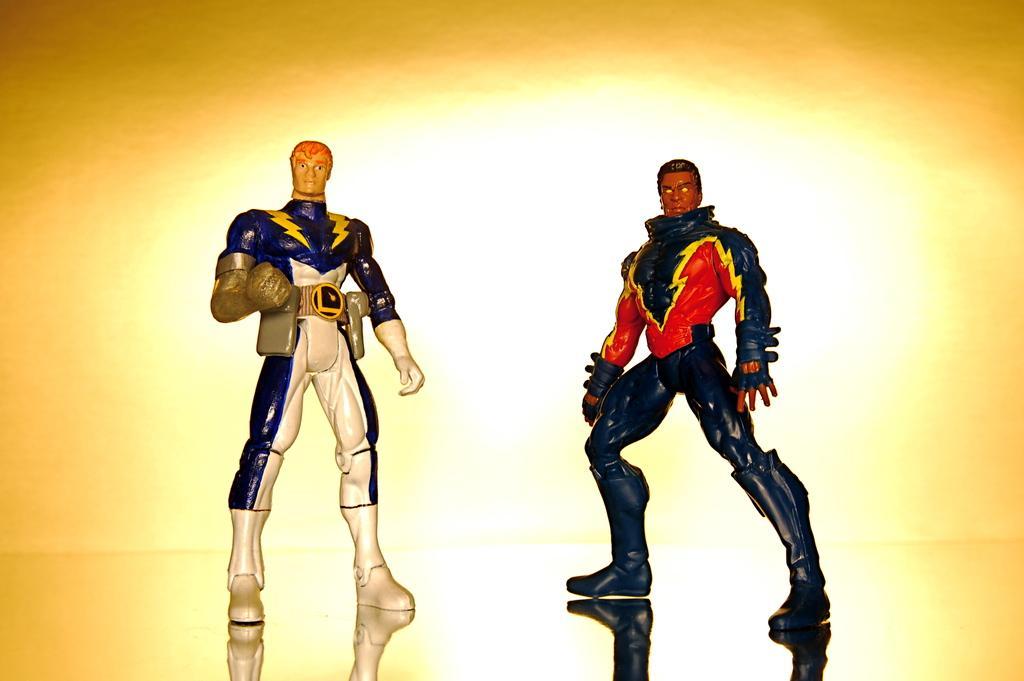Describe this image in one or two sentences. This image is an animated image. At the bottom of the image there is a floor. In the middle of the image there are two toys on the floor. In this image the background is yellow in color. 